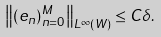<formula> <loc_0><loc_0><loc_500><loc_500>\left \| ( e _ { n } ) _ { n = 0 } ^ { M } \right \| _ { L ^ { \infty } ( W ) } \leq C \delta .</formula> 